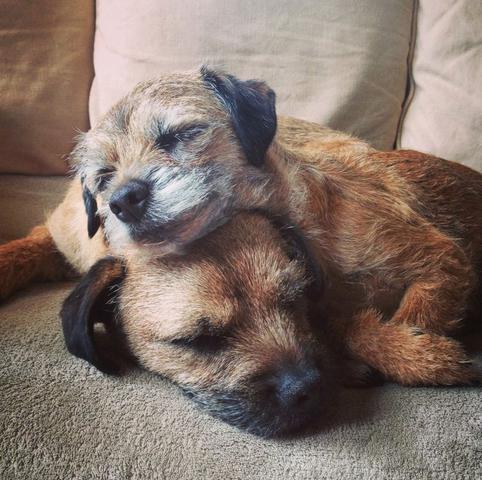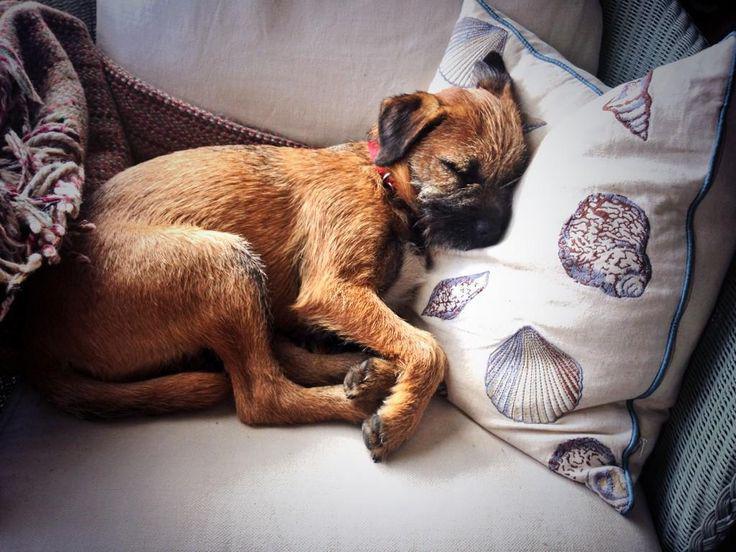The first image is the image on the left, the second image is the image on the right. Examine the images to the left and right. Is the description "A puppy is asleep on a wooden floor." accurate? Answer yes or no. No. The first image is the image on the left, the second image is the image on the right. For the images displayed, is the sentence "One dog is sleeping directly on a hard, wood-look floor." factually correct? Answer yes or no. No. 